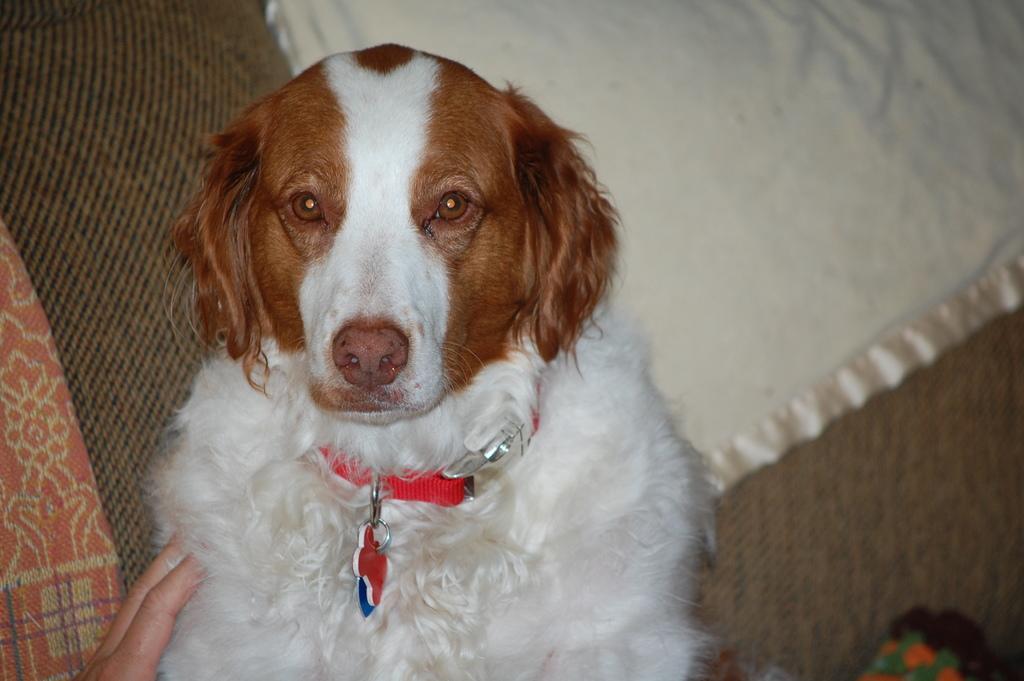Can you describe this image briefly? In this image we can see there is a person's hand holding a dog. And at the back it looks like a couch, on that there are clothes and object. 